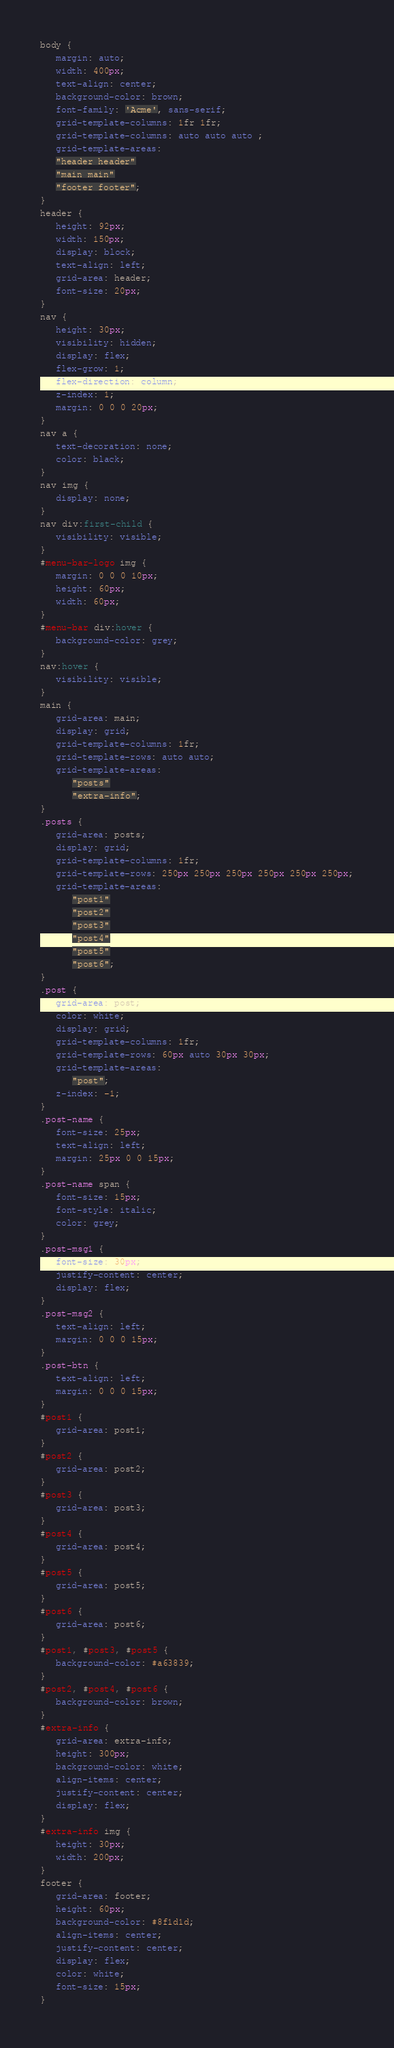Convert code to text. <code><loc_0><loc_0><loc_500><loc_500><_CSS_>body {
   margin: auto;
   width: 400px;
   text-align: center;
   background-color: brown;
   font-family: 'Acme', sans-serif;
   grid-template-columns: 1fr 1fr;
   grid-template-columns: auto auto auto ;
   grid-template-areas: 
   "header header"
   "main main"
   "footer footer";
}
header {
   height: 92px;
   width: 150px;
   display: block;
   text-align: left;
   grid-area: header;
   font-size: 20px;
}
nav {
   height: 30px;
   visibility: hidden;
   display: flex;
   flex-grow: 1;
   flex-direction: column;
   z-index: 1;
   margin: 0 0 0 20px;
}
nav a {
   text-decoration: none;
   color: black;
}
nav img {
   display: none;
}
nav div:first-child {
   visibility: visible;
}
#menu-bar-logo img {
   margin: 0 0 0 10px;
   height: 60px;
   width: 60px;
}
#menu-bar div:hover {
   background-color: grey;
}
nav:hover {
   visibility: visible;
}
main {
   grid-area: main;
   display: grid;
   grid-template-columns: 1fr;
   grid-template-rows: auto auto;
   grid-template-areas: 
      "posts"
      "extra-info";
}
.posts {
   grid-area: posts;
   display: grid;
   grid-template-columns: 1fr;
   grid-template-rows: 250px 250px 250px 250px 250px 250px;
   grid-template-areas:
      "post1"
      "post2"
      "post3"
      "post4"
      "post5" 
      "post6";
}
.post {
   grid-area: post;
   color: white;
   display: grid;
   grid-template-columns: 1fr;
   grid-template-rows: 60px auto 30px 30px;
   grid-template-areas: 
      "post";
   z-index: -1;
}
.post-name {
   font-size: 25px;
   text-align: left;
   margin: 25px 0 0 15px;
}
.post-name span {
   font-size: 15px;
   font-style: italic;
   color: grey;
}
.post-msg1 {
   font-size: 30px;
   justify-content: center;
   display: flex;
}
.post-msg2 {
   text-align: left;
   margin: 0 0 0 15px;
}
.post-btn {
   text-align: left;
   margin: 0 0 0 15px;
}
#post1 {
   grid-area: post1;
}
#post2 {
   grid-area: post2;
}
#post3 {
   grid-area: post3;
}
#post4 {
   grid-area: post4;
}
#post5 {
   grid-area: post5;
}
#post6 {
   grid-area: post6;
}
#post1, #post3, #post5 {
   background-color: #a63839;
}
#post2, #post4, #post6 {
   background-color: brown;
}
#extra-info {
   grid-area: extra-info;
   height: 300px;
   background-color: white;
   align-items: center;
   justify-content: center;
   display: flex;
}
#extra-info img {
   height: 30px;
   width: 200px;
}
footer {
   grid-area: footer;
   height: 60px;
   background-color: #8f1d1d;
   align-items: center;
   justify-content: center;
   display: flex;
   color: white;
   font-size: 15px;
}
</code> 